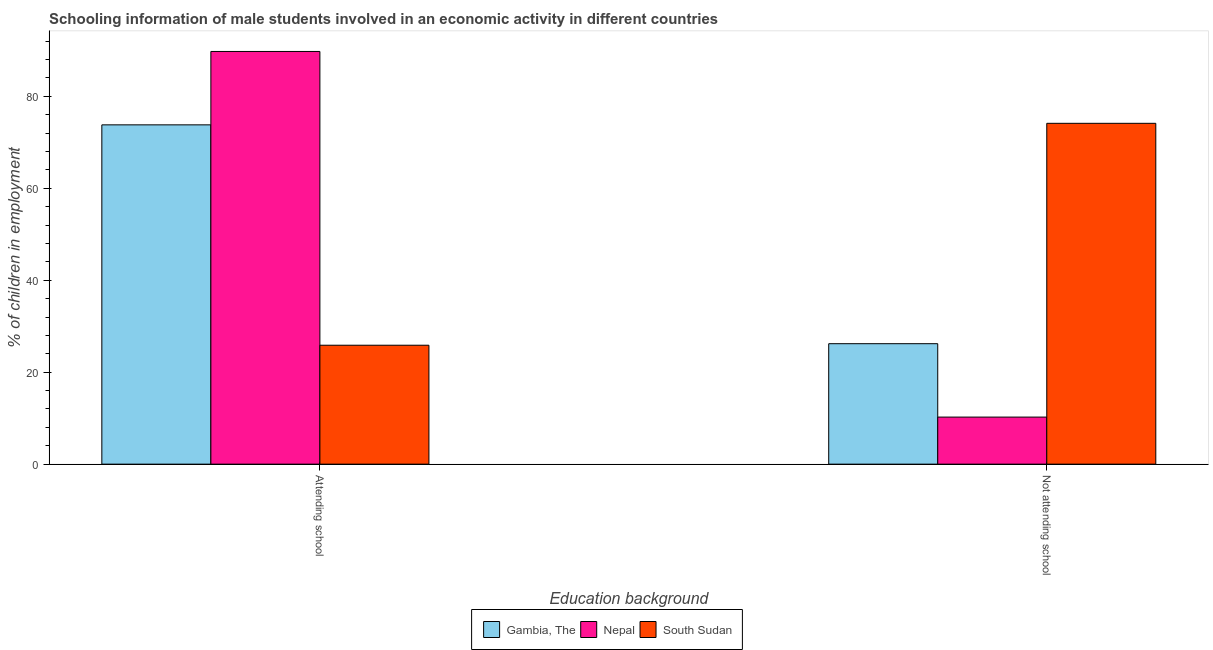How many groups of bars are there?
Your answer should be very brief. 2. Are the number of bars on each tick of the X-axis equal?
Offer a very short reply. Yes. How many bars are there on the 2nd tick from the right?
Provide a succinct answer. 3. What is the label of the 1st group of bars from the left?
Ensure brevity in your answer.  Attending school. What is the percentage of employed males who are attending school in Nepal?
Give a very brief answer. 89.76. Across all countries, what is the maximum percentage of employed males who are attending school?
Make the answer very short. 89.76. Across all countries, what is the minimum percentage of employed males who are not attending school?
Keep it short and to the point. 10.24. In which country was the percentage of employed males who are attending school maximum?
Offer a terse response. Nepal. In which country was the percentage of employed males who are not attending school minimum?
Provide a succinct answer. Nepal. What is the total percentage of employed males who are not attending school in the graph?
Keep it short and to the point. 110.57. What is the difference between the percentage of employed males who are attending school in South Sudan and that in Nepal?
Offer a very short reply. -63.9. What is the difference between the percentage of employed males who are not attending school in Gambia, The and the percentage of employed males who are attending school in South Sudan?
Provide a short and direct response. 0.33. What is the average percentage of employed males who are attending school per country?
Your answer should be compact. 63.14. What is the difference between the percentage of employed males who are attending school and percentage of employed males who are not attending school in Nepal?
Your response must be concise. 79.53. What is the ratio of the percentage of employed males who are attending school in Nepal to that in South Sudan?
Your answer should be compact. 3.47. In how many countries, is the percentage of employed males who are not attending school greater than the average percentage of employed males who are not attending school taken over all countries?
Offer a very short reply. 1. What does the 3rd bar from the left in Attending school represents?
Ensure brevity in your answer.  South Sudan. What does the 1st bar from the right in Not attending school represents?
Provide a succinct answer. South Sudan. How many bars are there?
Offer a terse response. 6. How many countries are there in the graph?
Your answer should be compact. 3. What is the difference between two consecutive major ticks on the Y-axis?
Your answer should be compact. 20. Are the values on the major ticks of Y-axis written in scientific E-notation?
Provide a succinct answer. No. Does the graph contain grids?
Ensure brevity in your answer.  No. How are the legend labels stacked?
Keep it short and to the point. Horizontal. What is the title of the graph?
Provide a short and direct response. Schooling information of male students involved in an economic activity in different countries. What is the label or title of the X-axis?
Provide a succinct answer. Education background. What is the label or title of the Y-axis?
Your answer should be very brief. % of children in employment. What is the % of children in employment of Gambia, The in Attending school?
Provide a short and direct response. 73.8. What is the % of children in employment of Nepal in Attending school?
Keep it short and to the point. 89.76. What is the % of children in employment in South Sudan in Attending school?
Provide a short and direct response. 25.87. What is the % of children in employment of Gambia, The in Not attending school?
Your answer should be compact. 26.2. What is the % of children in employment of Nepal in Not attending school?
Make the answer very short. 10.24. What is the % of children in employment of South Sudan in Not attending school?
Provide a succinct answer. 74.13. Across all Education background, what is the maximum % of children in employment in Gambia, The?
Offer a terse response. 73.8. Across all Education background, what is the maximum % of children in employment of Nepal?
Your answer should be compact. 89.76. Across all Education background, what is the maximum % of children in employment in South Sudan?
Offer a very short reply. 74.13. Across all Education background, what is the minimum % of children in employment of Gambia, The?
Provide a succinct answer. 26.2. Across all Education background, what is the minimum % of children in employment in Nepal?
Offer a terse response. 10.24. Across all Education background, what is the minimum % of children in employment of South Sudan?
Your answer should be very brief. 25.87. What is the total % of children in employment in Nepal in the graph?
Give a very brief answer. 100. What is the difference between the % of children in employment in Gambia, The in Attending school and that in Not attending school?
Provide a short and direct response. 47.6. What is the difference between the % of children in employment of Nepal in Attending school and that in Not attending school?
Your response must be concise. 79.53. What is the difference between the % of children in employment of South Sudan in Attending school and that in Not attending school?
Your answer should be very brief. -48.27. What is the difference between the % of children in employment in Gambia, The in Attending school and the % of children in employment in Nepal in Not attending school?
Ensure brevity in your answer.  63.56. What is the difference between the % of children in employment in Gambia, The in Attending school and the % of children in employment in South Sudan in Not attending school?
Provide a succinct answer. -0.33. What is the difference between the % of children in employment of Nepal in Attending school and the % of children in employment of South Sudan in Not attending school?
Provide a succinct answer. 15.63. What is the average % of children in employment of Gambia, The per Education background?
Your answer should be compact. 50. What is the average % of children in employment in South Sudan per Education background?
Keep it short and to the point. 50. What is the difference between the % of children in employment in Gambia, The and % of children in employment in Nepal in Attending school?
Keep it short and to the point. -15.96. What is the difference between the % of children in employment of Gambia, The and % of children in employment of South Sudan in Attending school?
Keep it short and to the point. 47.93. What is the difference between the % of children in employment of Nepal and % of children in employment of South Sudan in Attending school?
Make the answer very short. 63.9. What is the difference between the % of children in employment of Gambia, The and % of children in employment of Nepal in Not attending school?
Provide a succinct answer. 15.96. What is the difference between the % of children in employment in Gambia, The and % of children in employment in South Sudan in Not attending school?
Provide a succinct answer. -47.93. What is the difference between the % of children in employment of Nepal and % of children in employment of South Sudan in Not attending school?
Make the answer very short. -63.9. What is the ratio of the % of children in employment in Gambia, The in Attending school to that in Not attending school?
Make the answer very short. 2.82. What is the ratio of the % of children in employment of Nepal in Attending school to that in Not attending school?
Keep it short and to the point. 8.77. What is the ratio of the % of children in employment in South Sudan in Attending school to that in Not attending school?
Make the answer very short. 0.35. What is the difference between the highest and the second highest % of children in employment of Gambia, The?
Provide a short and direct response. 47.6. What is the difference between the highest and the second highest % of children in employment of Nepal?
Give a very brief answer. 79.53. What is the difference between the highest and the second highest % of children in employment in South Sudan?
Your response must be concise. 48.27. What is the difference between the highest and the lowest % of children in employment of Gambia, The?
Make the answer very short. 47.6. What is the difference between the highest and the lowest % of children in employment of Nepal?
Offer a terse response. 79.53. What is the difference between the highest and the lowest % of children in employment in South Sudan?
Ensure brevity in your answer.  48.27. 